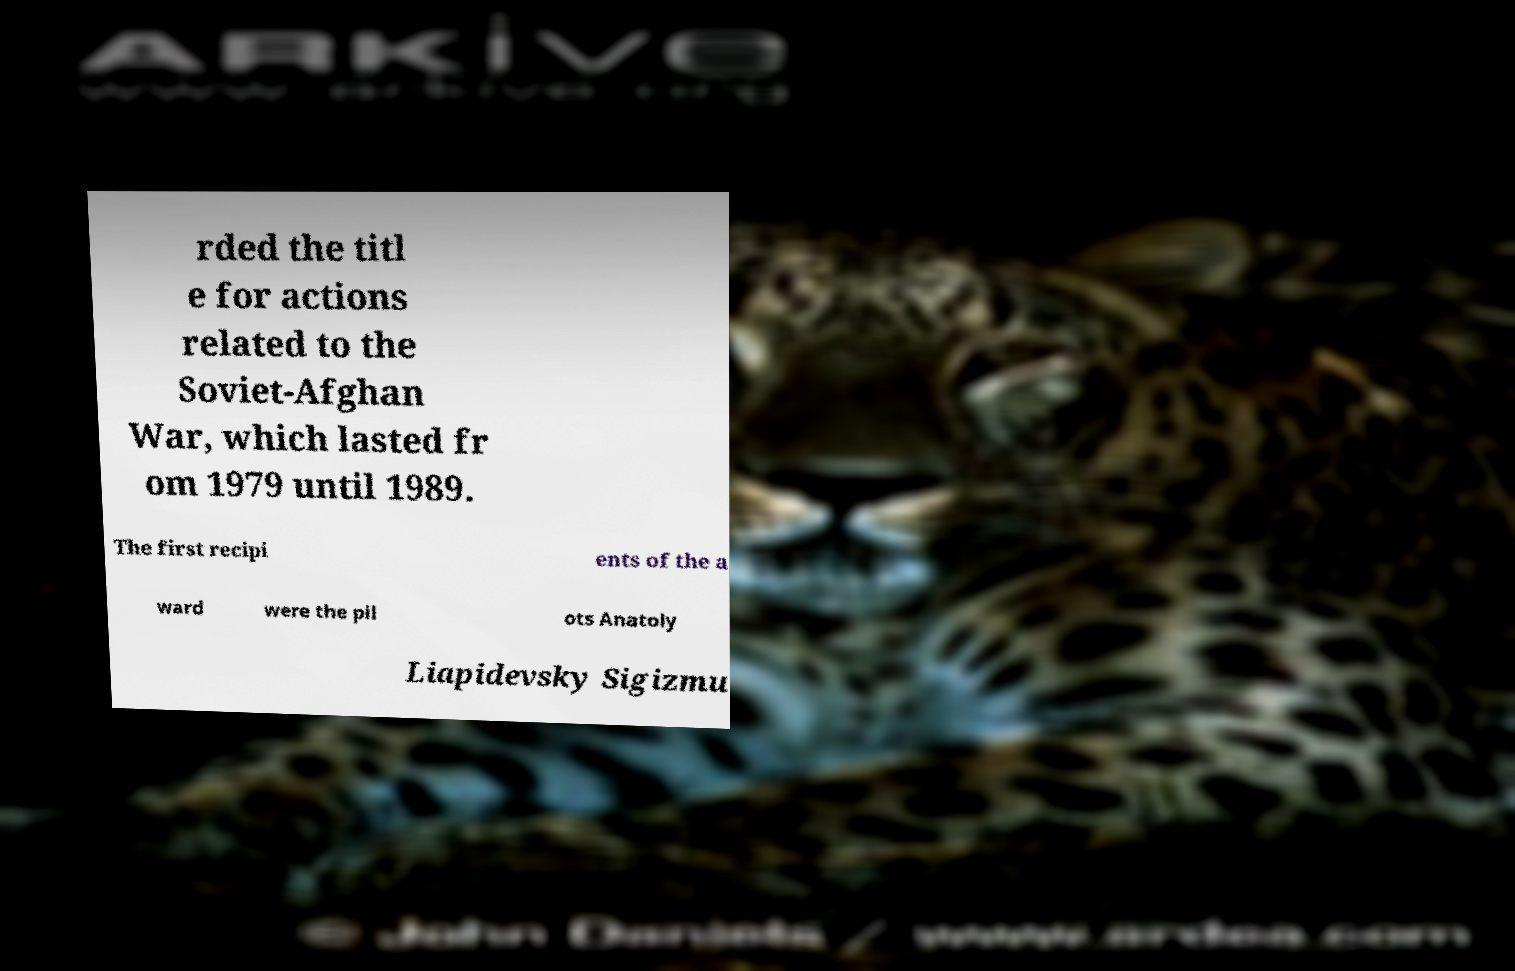Could you extract and type out the text from this image? rded the titl e for actions related to the Soviet-Afghan War, which lasted fr om 1979 until 1989. The first recipi ents of the a ward were the pil ots Anatoly Liapidevsky Sigizmu 